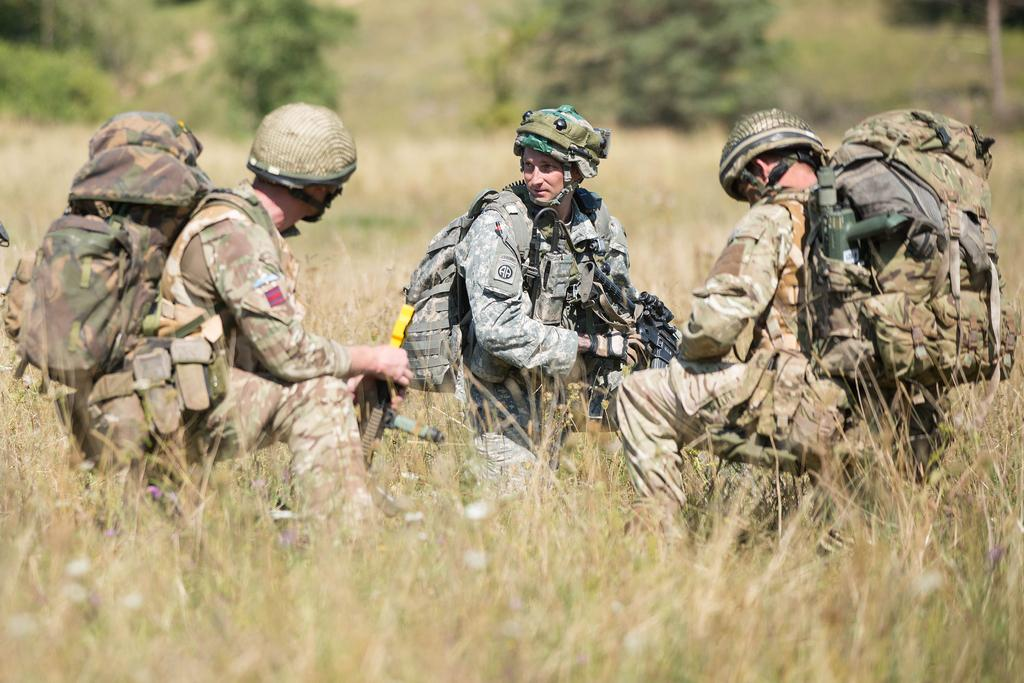What are the people in the image doing with their hands? Some people are carrying bags, and two people are holding guns in the image. What is the ground surface like in the image? The ground is covered with grass in the image. What type of vegetation can be seen in the image? There are trees in the image. What is the governor doing in the image? There is no governor present in the image. How many passengers are visible in the image? The term "passenger" is not mentioned in the provided facts, and therefore it cannot be determined from the image. 